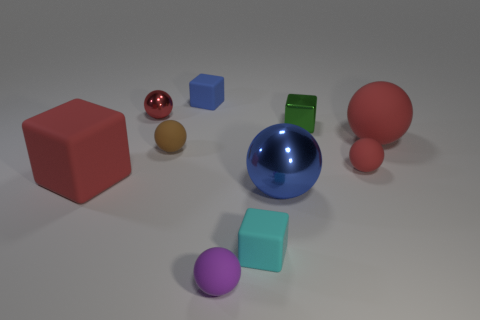Can you tell me which objects seem to be emitting more light or have reflective surfaces? Certainly, in the image, the shiny sphere and the small redish-brown sphere both have reflective surfaces that emit more light compared to the other objects. Their smooth textures and the way they catch the light are indicative of reflective properties. 